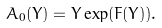<formula> <loc_0><loc_0><loc_500><loc_500>A _ { 0 } ( Y ) = Y \exp ( F ( Y ) ) .</formula> 